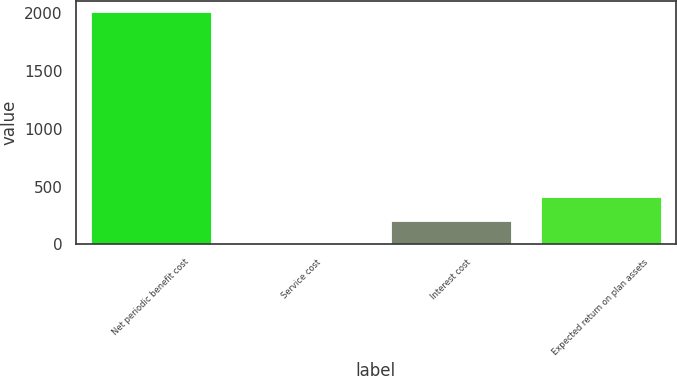Convert chart. <chart><loc_0><loc_0><loc_500><loc_500><bar_chart><fcel>Net periodic benefit cost<fcel>Service cost<fcel>Interest cost<fcel>Expected return on plan assets<nl><fcel>2010<fcel>6<fcel>206.4<fcel>406.8<nl></chart> 